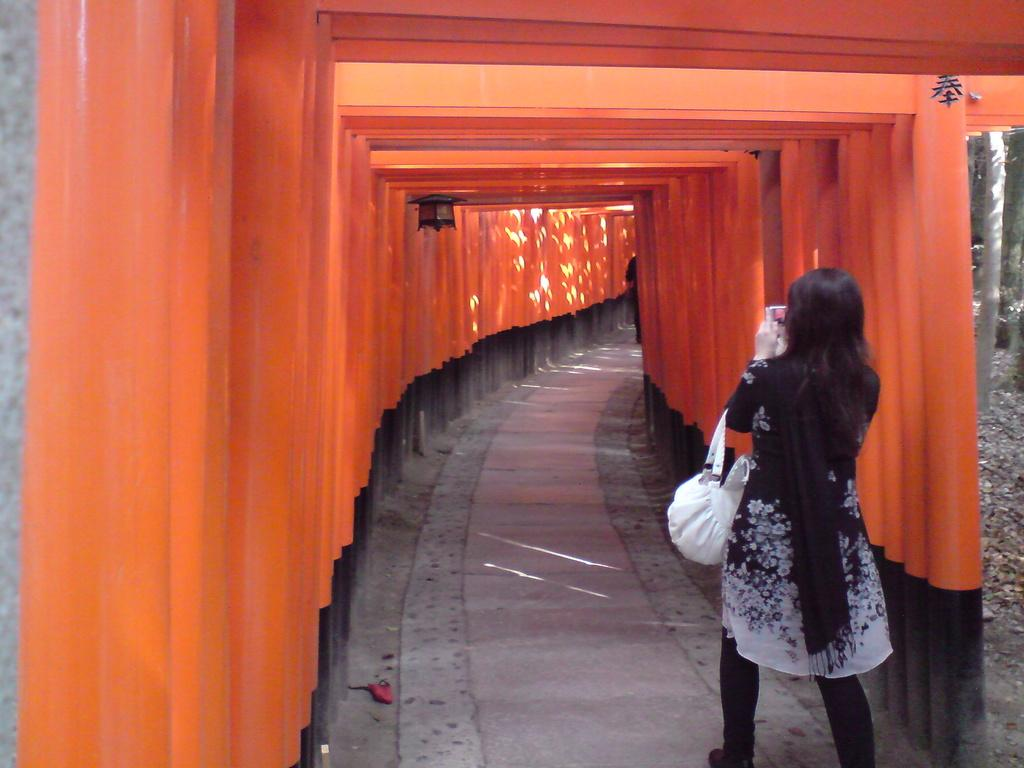Who is the main subject in the image? There is a woman in the image. What is the woman doing in the image? The woman is walking in the image. What can be seen in the foreground of the image? There is a tunnel made up of some objects in the foreground of the image. What is located beside the tunnel in the image? There are trees beside the tunnel in the image. What type of shoe is the minister wearing in the image? There is no minister or shoe present in the image. 